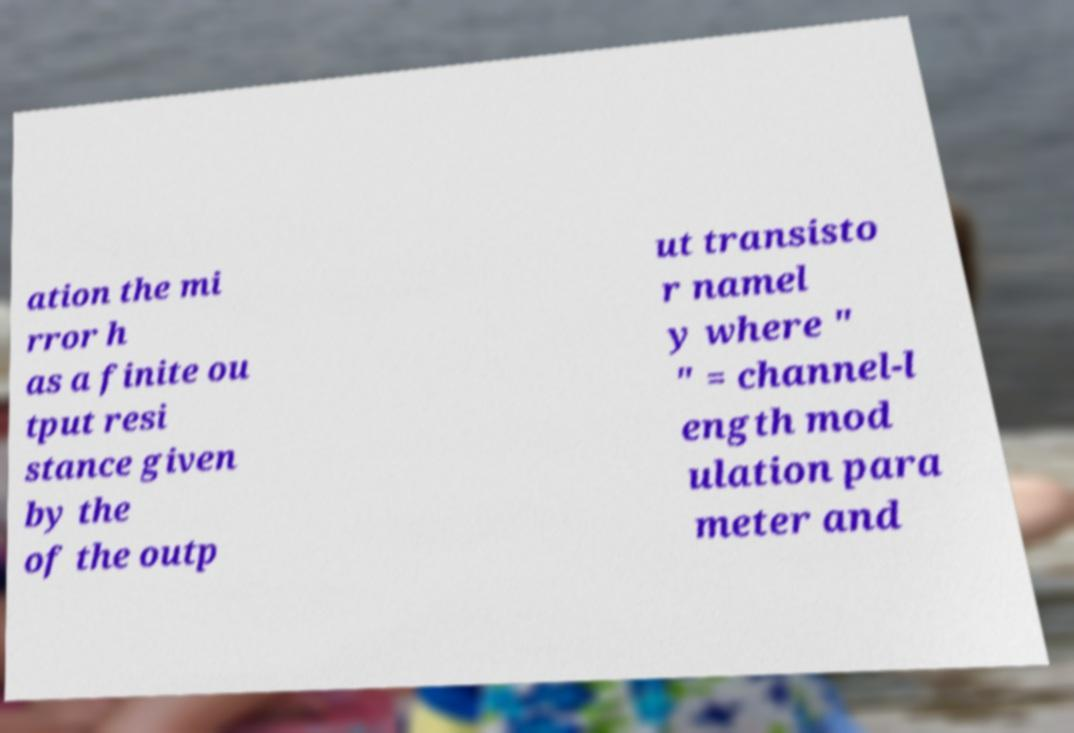Can you read and provide the text displayed in the image?This photo seems to have some interesting text. Can you extract and type it out for me? ation the mi rror h as a finite ou tput resi stance given by the of the outp ut transisto r namel y where " " = channel-l ength mod ulation para meter and 